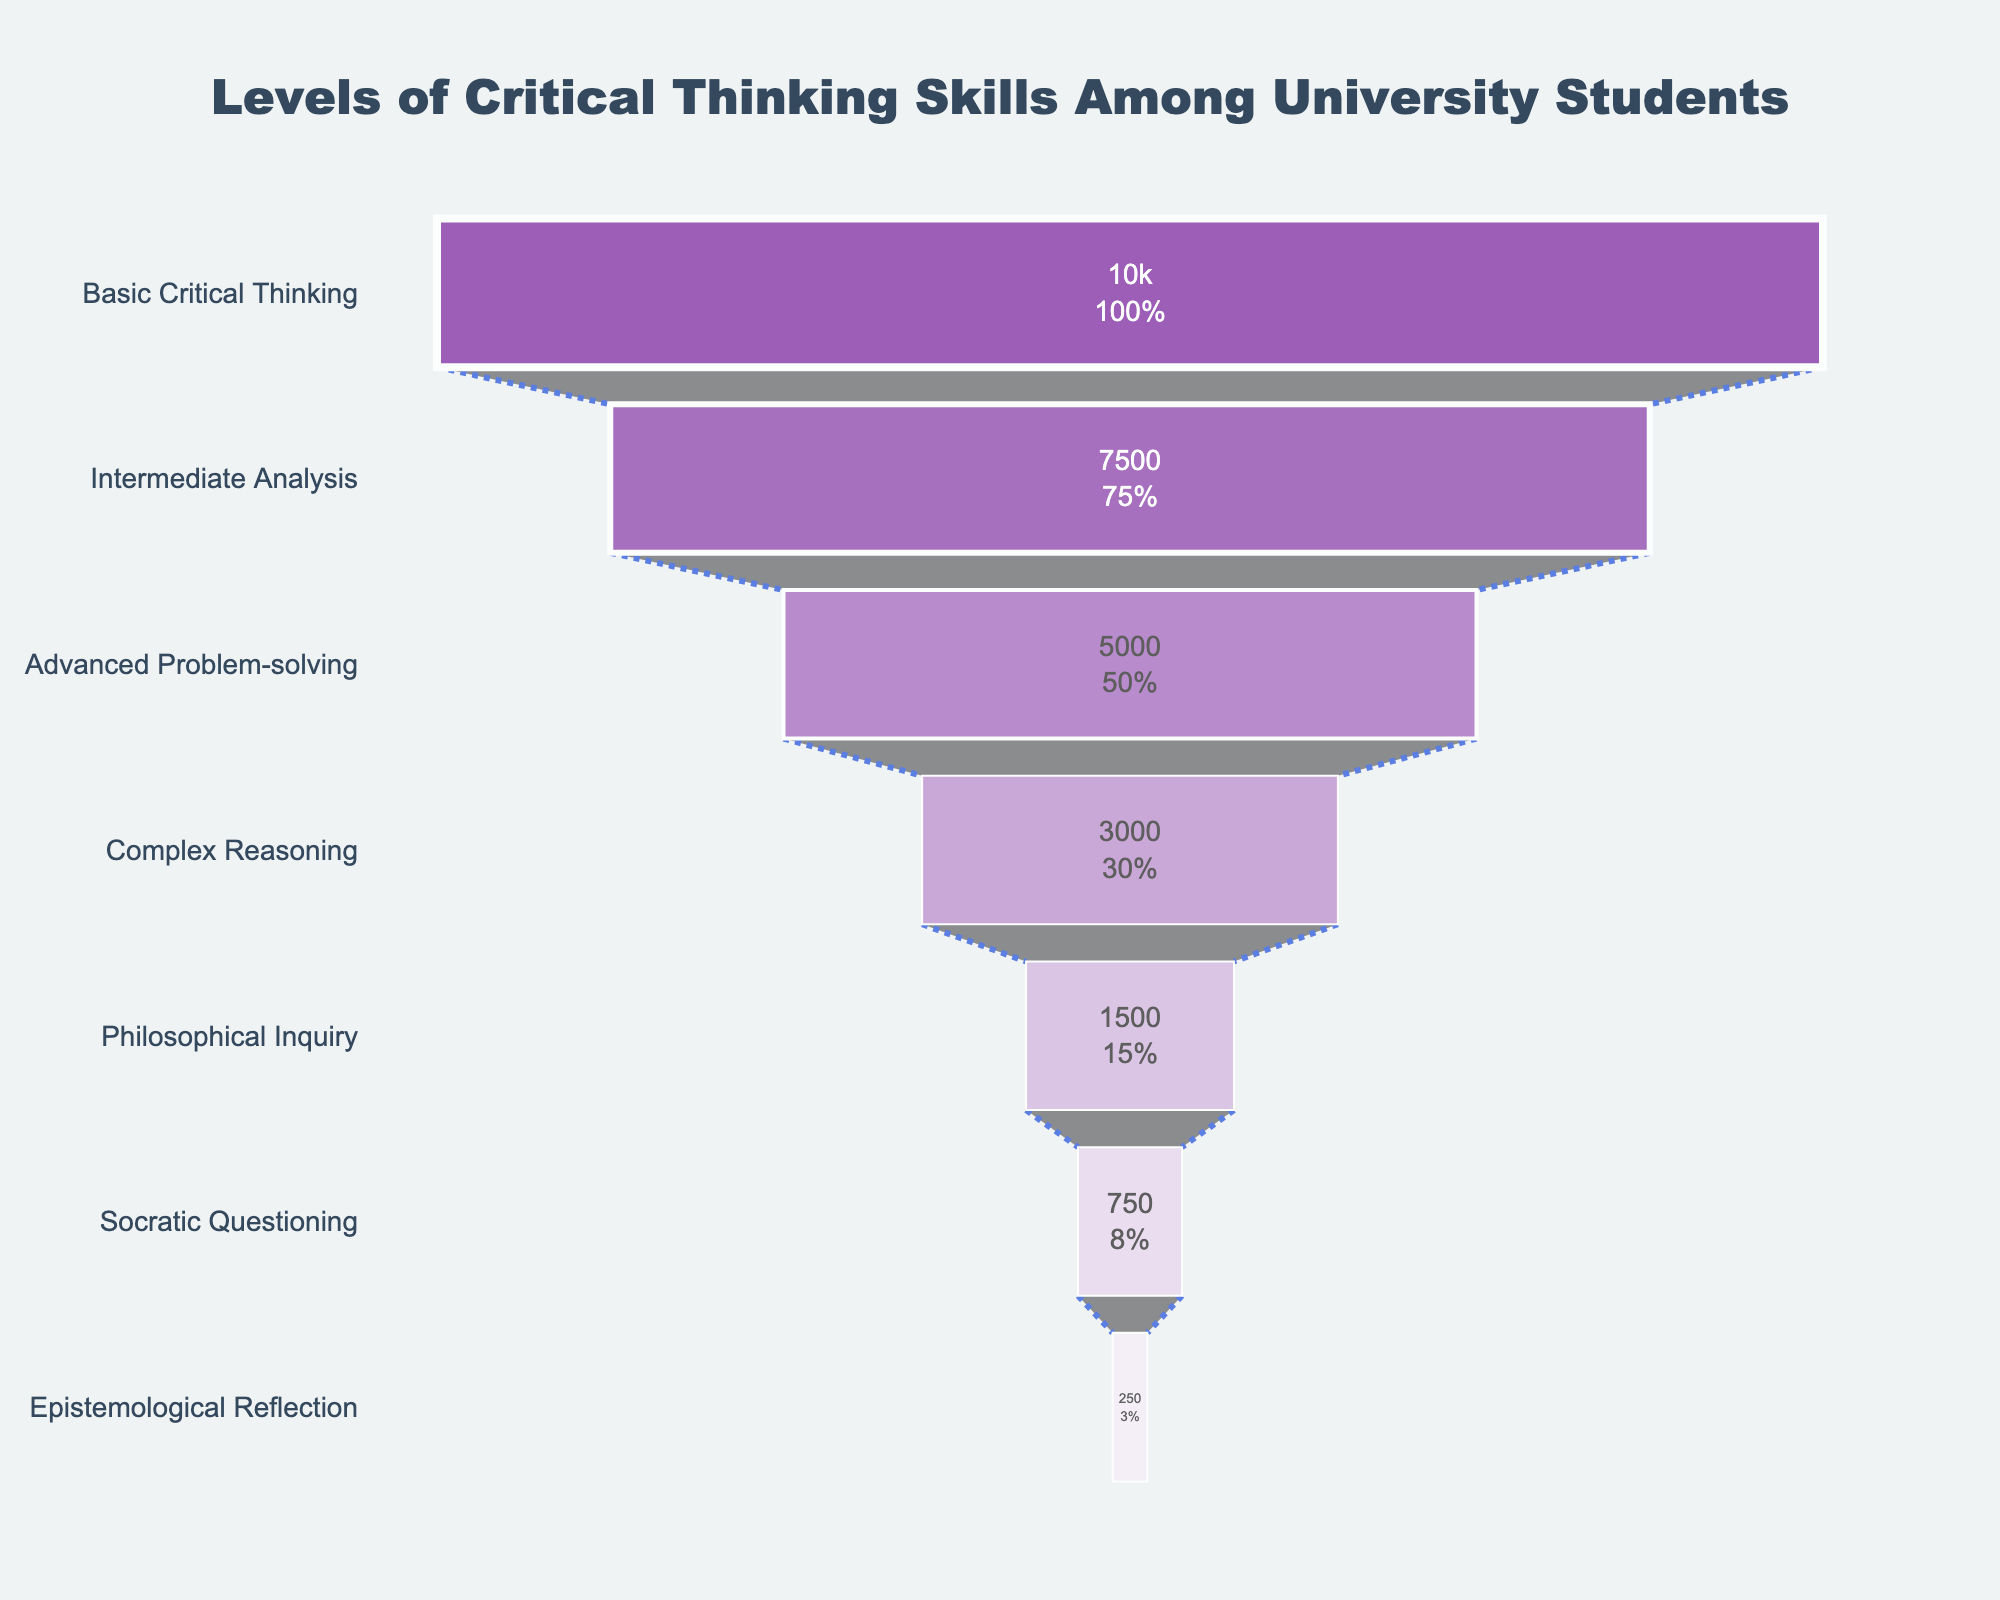How many levels of critical thinking skills are represented in the funnel chart? By observing the funnel chart, count the different levels labelled on the y-axis. There are seven levels: Basic Critical Thinking, Intermediate Analysis, Advanced Problem-solving, Complex Reasoning, Philosophical Inquiry, Socratic Questioning, and Epistemological Reflection.
Answer: Seven Which level has the highest number of students? The funnel chart shows the number of students associated with each level, with "Basic Critical Thinking" having the largest section at the top. This signifies the highest number of students, which is 10,000.
Answer: Basic Critical Thinking How many students are at the Advanced Problem-solving level? From the funnel chart, we see the "Advanced Problem-solving" level and the number of students in that section, which is 5,000.
Answer: 5,000 What is the difference in the number of students between Intermediate Analysis and Epistemological Reflection? According to the funnel chart, Intermediate Analysis has 7,500 students and Epistemological Reflection has 250 students. The difference is 7,500 - 250.
Answer: 7,250 How many students are there in total at all levels? Sum up the number of students at each level: 10,000 (Basic) + 7,500 (Intermediate) + 5,000 (Advanced) + 3,000 (Complex) + 1,500 (Philosophical) + 750 (Socratic) + 250 (Epistemological). The total is 28,000.
Answer: 28,000 Which level has the smallest percentage of students? From the funnel chart, Epistemological Reflection has the smallest section at the bottom, which signifies the smallest number of students and percentage. This is 250 students.
Answer: Epistemological Reflection What's the combined number of students at the top three levels? The top three levels in the funnel chart are Basic Critical Thinking (10,000), Intermediate Analysis (7,500), and Advanced Problem-solving (5,000). Summing these gives 10,000 + 7,500 + 5,000.
Answer: 22,500 Is the number of students at Philosophical Inquiry greater than Socratic Questioning? By looking at the funnel chart, the section for Philosophical Inquiry has 1,500 students while the section for Socratic Questioning has 750 students. 1,500 > 750.
Answer: Yes How many students are at the Complex Reasoning level relative to Advanced Problem-solving? Compare the number of students in each section. Complex Reasoning has 3,000 students, while Advanced Problem-solving has 5,000. 3,000/5,000 = 0.6.
Answer: 60% In terms of percentage, how much larger is the Basic Critical Thinking level compared to the Intermediate Analysis level? Basic Critical Thinking has 10,000 students and Intermediate Analysis has 7,500. Calculate the percentage difference: ((10,000 - 7,500) / 10,000) * 100%. This equals 25%.
Answer: 25% 